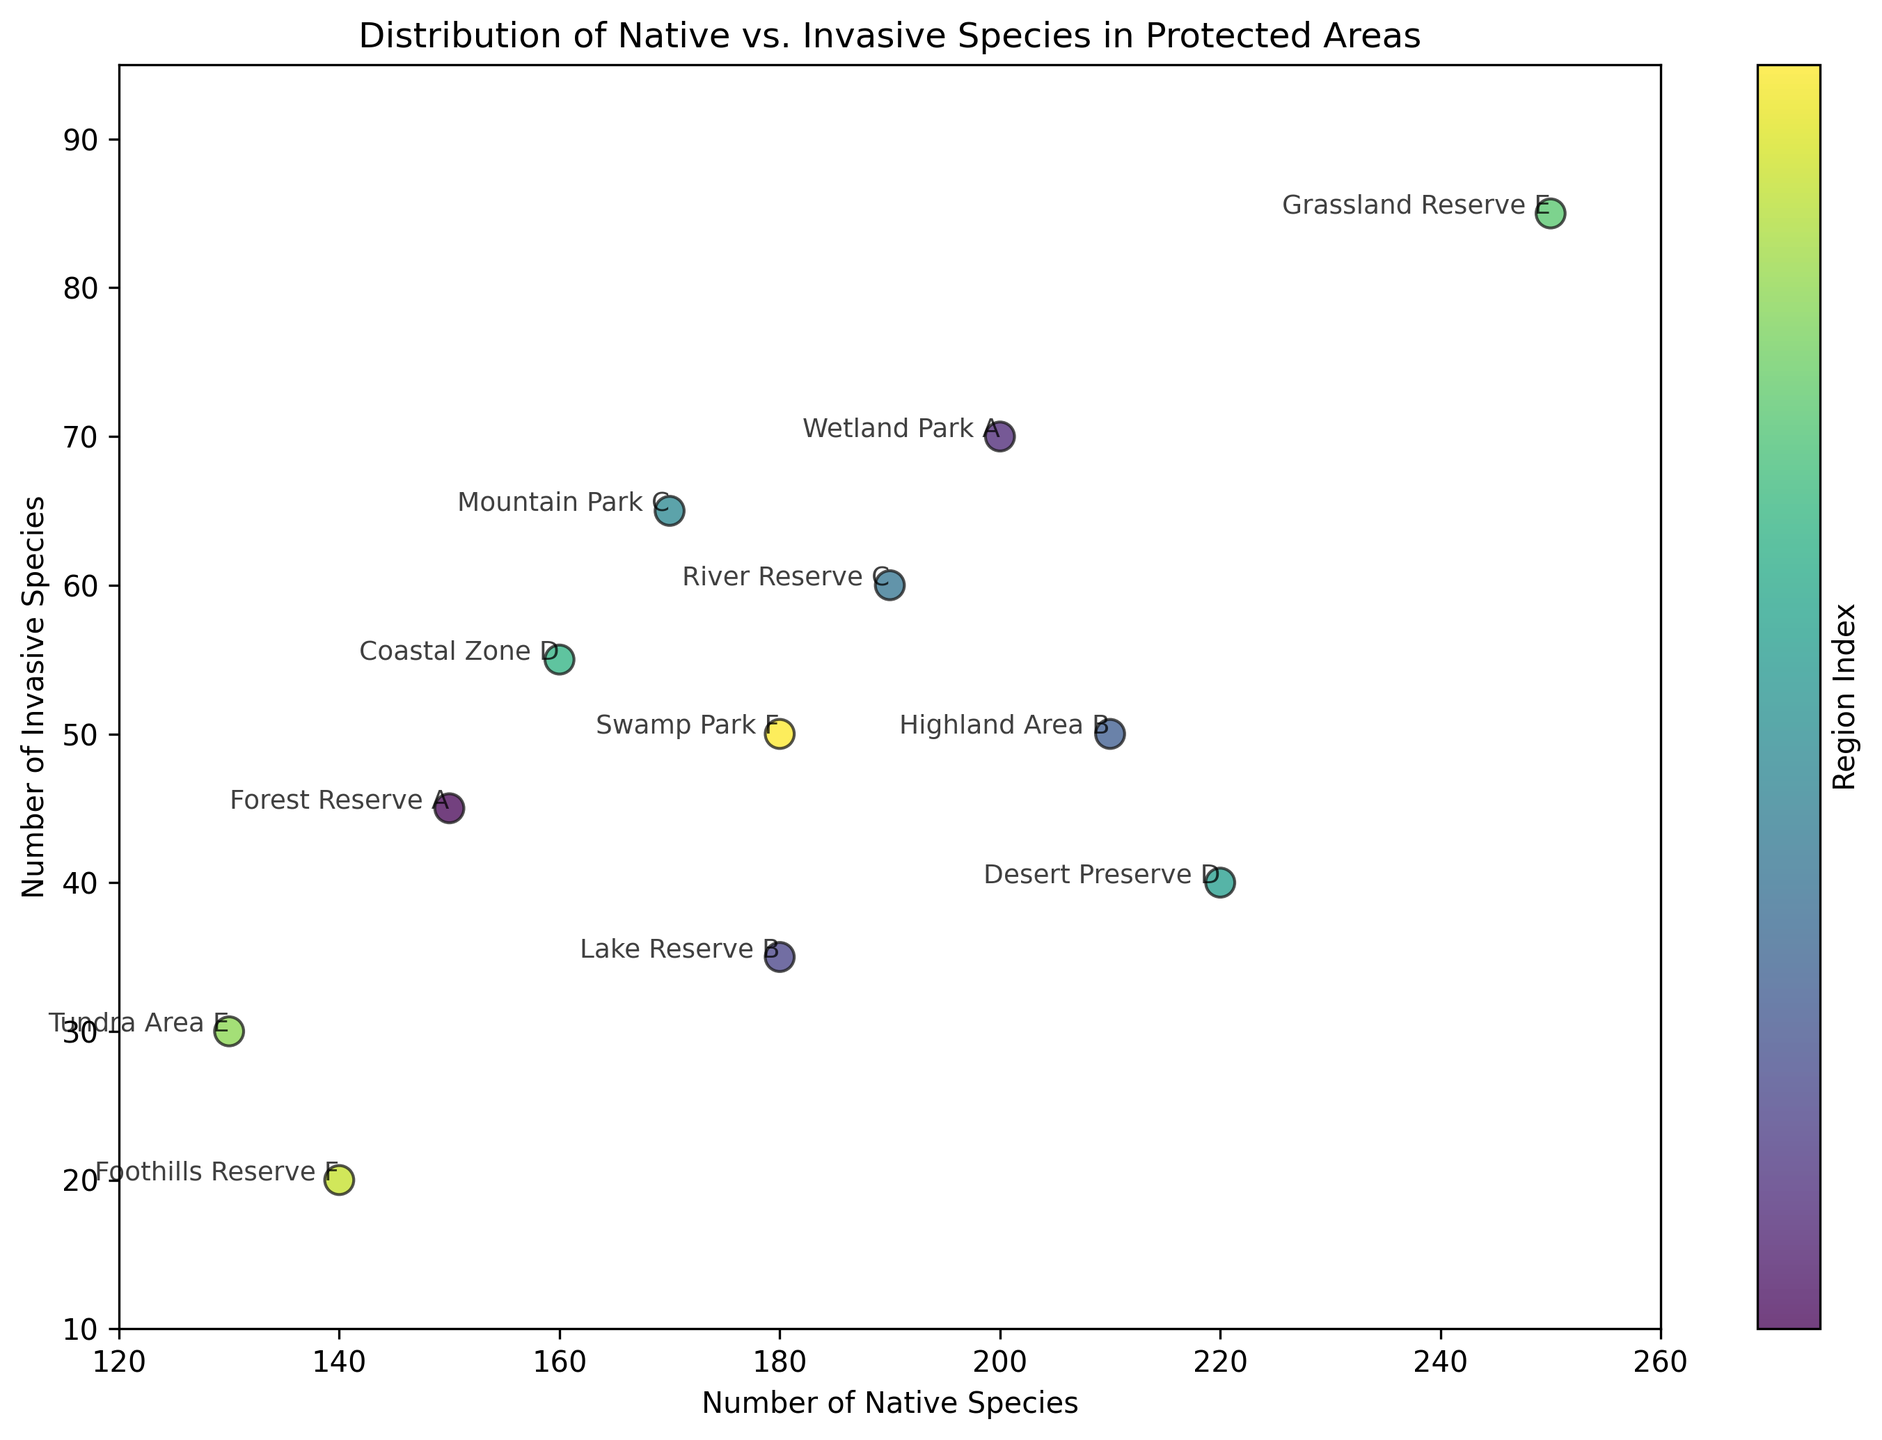Which protected area has the highest number of native species? Look at the x-axis values and identify the point with the highest x-value. The highest x-value corresponds to Grassland Reserve E with 250 native species.
Answer: Grassland Reserve E Which protected area has the lowest number of invasive species? Identify the point with the lowest y-axis value. The lowest y-value corresponds to Tundra Area E with 30 invasive species.
Answer: Tundra Area E Which region has the protected area with the most balanced number of native and invasive species? The most balanced numbers will be where the points are closest to the diagonal line y=x on the plot. Comparing visually, Highland Area B in Region B (210 native and 50 invasive) is the closest to being balanced.
Answer: Region B How many protected areas have more than 200 native species? Count the number of points that are to the right of the x-value of 200. Wetland Park A, Highland Area B, Desert Preserve D, and Grassland Reserve E have more than 200 native species.
Answer: 4 Compare Desert Preserve D and Coastal Zone D. Which has more invasive species? Locate both points and compare their y-axis values. Desert Preserve D has 40 invasive species compared to Coastal Zone D's 55. Therefore, Coastal Zone D has more.
Answer: Coastal Zone D What is the total number of native species in Region A? Sum the x-values for the protected areas in Region A: Forest Reserve A (150) + Wetland Park A (200) = 350
Answer: 350 Which protected areas have both more than 180 native species and fewer than 50 invasive species? Identify points with x-values greater than 180 and y-values less than 50. These are Lake Reserve B and Desert Preserve D.
Answer: Lake Reserve B and Desert Preserve D Which protected area has the highest ratio of native to invasive species? Calculate the ratio of native to invasive species for each point and compare. Forest Reserve A (150/45 ≈ 3.33), Wetland Park A (200/70 ≈ 2.86), Lake Reserve B (180/35 ≈ 5.14), Highland Area B (210/50 ≈ 4.2), River Reserve C (190/60 ≈ 3.17), Mountain Park C (170/65 ≈ 2.62), Desert Preserve D (220/40 ≈ 5.5), Coastal Zone D (160/55 ≈ 2.91), Grassland Reserve E (250/85 ≈ 2.94), Tundra Area E (130/30 ≈ 4.33), Foothills Reserve F (140/20 = 7), Swamp Park F (180/50 = 3.6). Foothills Reserve F has the highest ratio.
Answer: Foothills Reserve F 